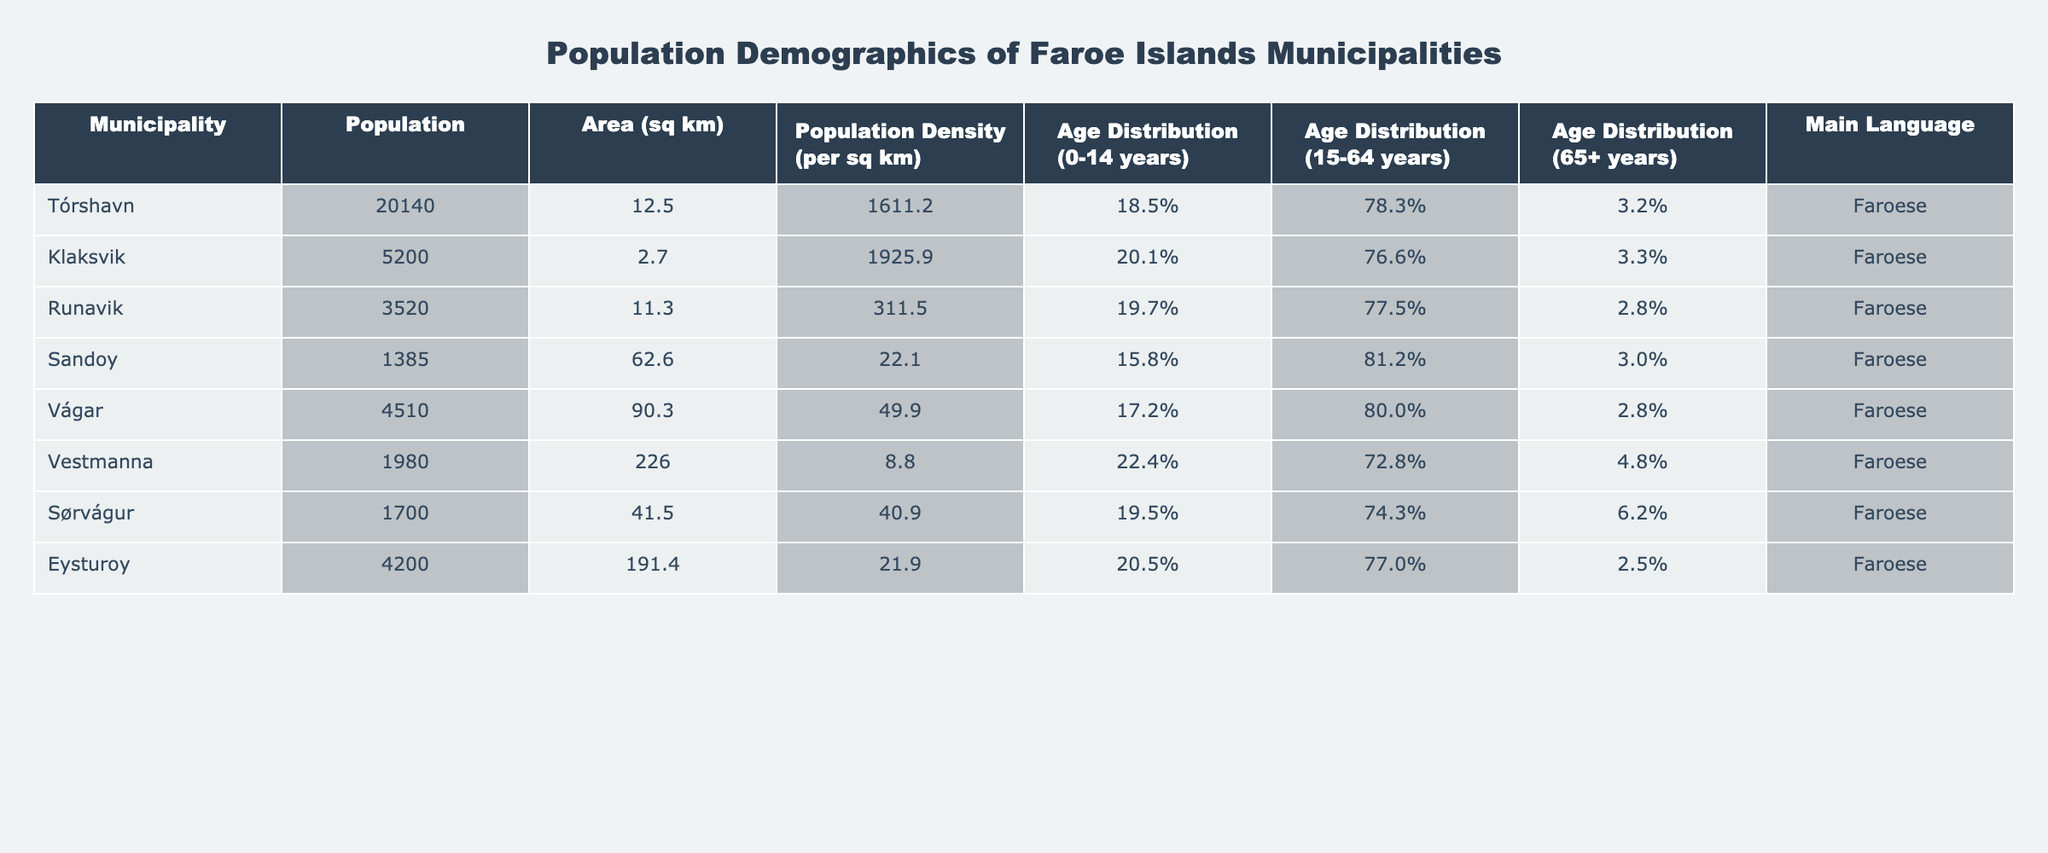What is the population of Tórshavn? The population of Tórshavn is stated directly in the table as 20140.
Answer: 20140 What is the area of Klaksvik in square kilometers? The area of Klaksvik is listed in the table as 2.7 square kilometers.
Answer: 2.7 Which municipality has the highest population density? By examining the "Population Density" column, Klaksvik has 1925.9 per square km, which is the highest density compared to other municipalities.
Answer: Klaksvik What percentage of the population in Sørvágur is aged 15-64 years? The table indicates that 74.3% of the population in Sørvágur falls within the age range of 15-64 years.
Answer: 74.3% What is the average population of the municipalities listed? To find the average, sum the populations: 20140 + 5200 + 3520 + 1385 + 4510 + 1980 + 1700 + 4200 =  33935. Dividing by the number of municipalities (8), we get: 33935 / 8 = 4241.875.
Answer: 4241.88 Is the main language spoken in all municipalities Faroese? The table shows that the main language for all municipalities listed is Faroese, confirming the statement to be true.
Answer: Yes How many municipalities have a population density greater than 1000 per square kilometer? From the table, only Tórshavn (1611.2), Klaksvik (1925.9), and Runavik (311.5) have a density greater than 1000, indicating 3 municipalities fit this criterion.
Answer: 3 What percentage of the population in Eysturoy is aged 65 years or older? The table states that 2.5% of the population in Eysturoy is aged 65 years or older, which is a direct reference from the age distribution data.
Answer: 2.5% Which municipality has the lowest population, and what is that population? By comparing the populations listed, Sandoy has the lowest population at 1385.
Answer: Sandoy, 1385 